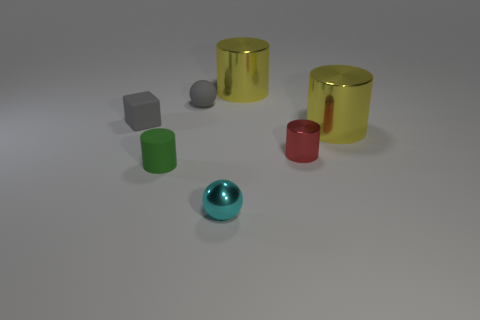Subtract 1 cylinders. How many cylinders are left? 3 Subtract all blue cylinders. Subtract all red spheres. How many cylinders are left? 4 Add 2 tiny purple rubber spheres. How many objects exist? 9 Subtract all cylinders. How many objects are left? 3 Subtract all gray rubber objects. Subtract all tiny spheres. How many objects are left? 3 Add 7 gray spheres. How many gray spheres are left? 8 Add 3 yellow metal objects. How many yellow metal objects exist? 5 Subtract 0 blue spheres. How many objects are left? 7 